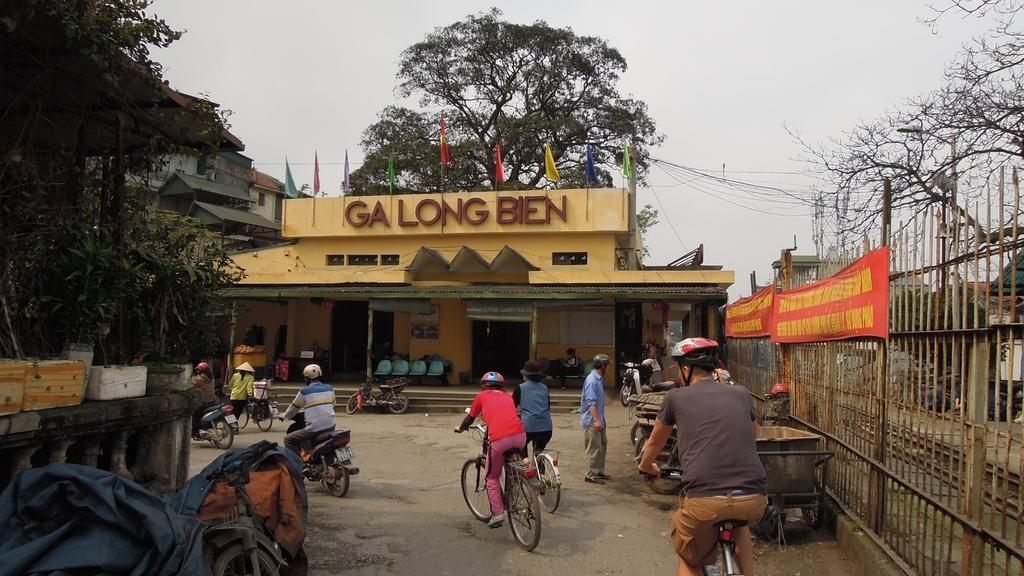What are the people doing in the image? People are passing by a building in the image. What mode of transportation are some people using? Some people are on cycles and some are on bikes. Can you describe the building in the image? The facts provided do not give any details about the building, so we cannot describe it. What type of wave can be seen crashing on the shore in the image? There is no wave or shore present in the image; it features people passing by a building. 